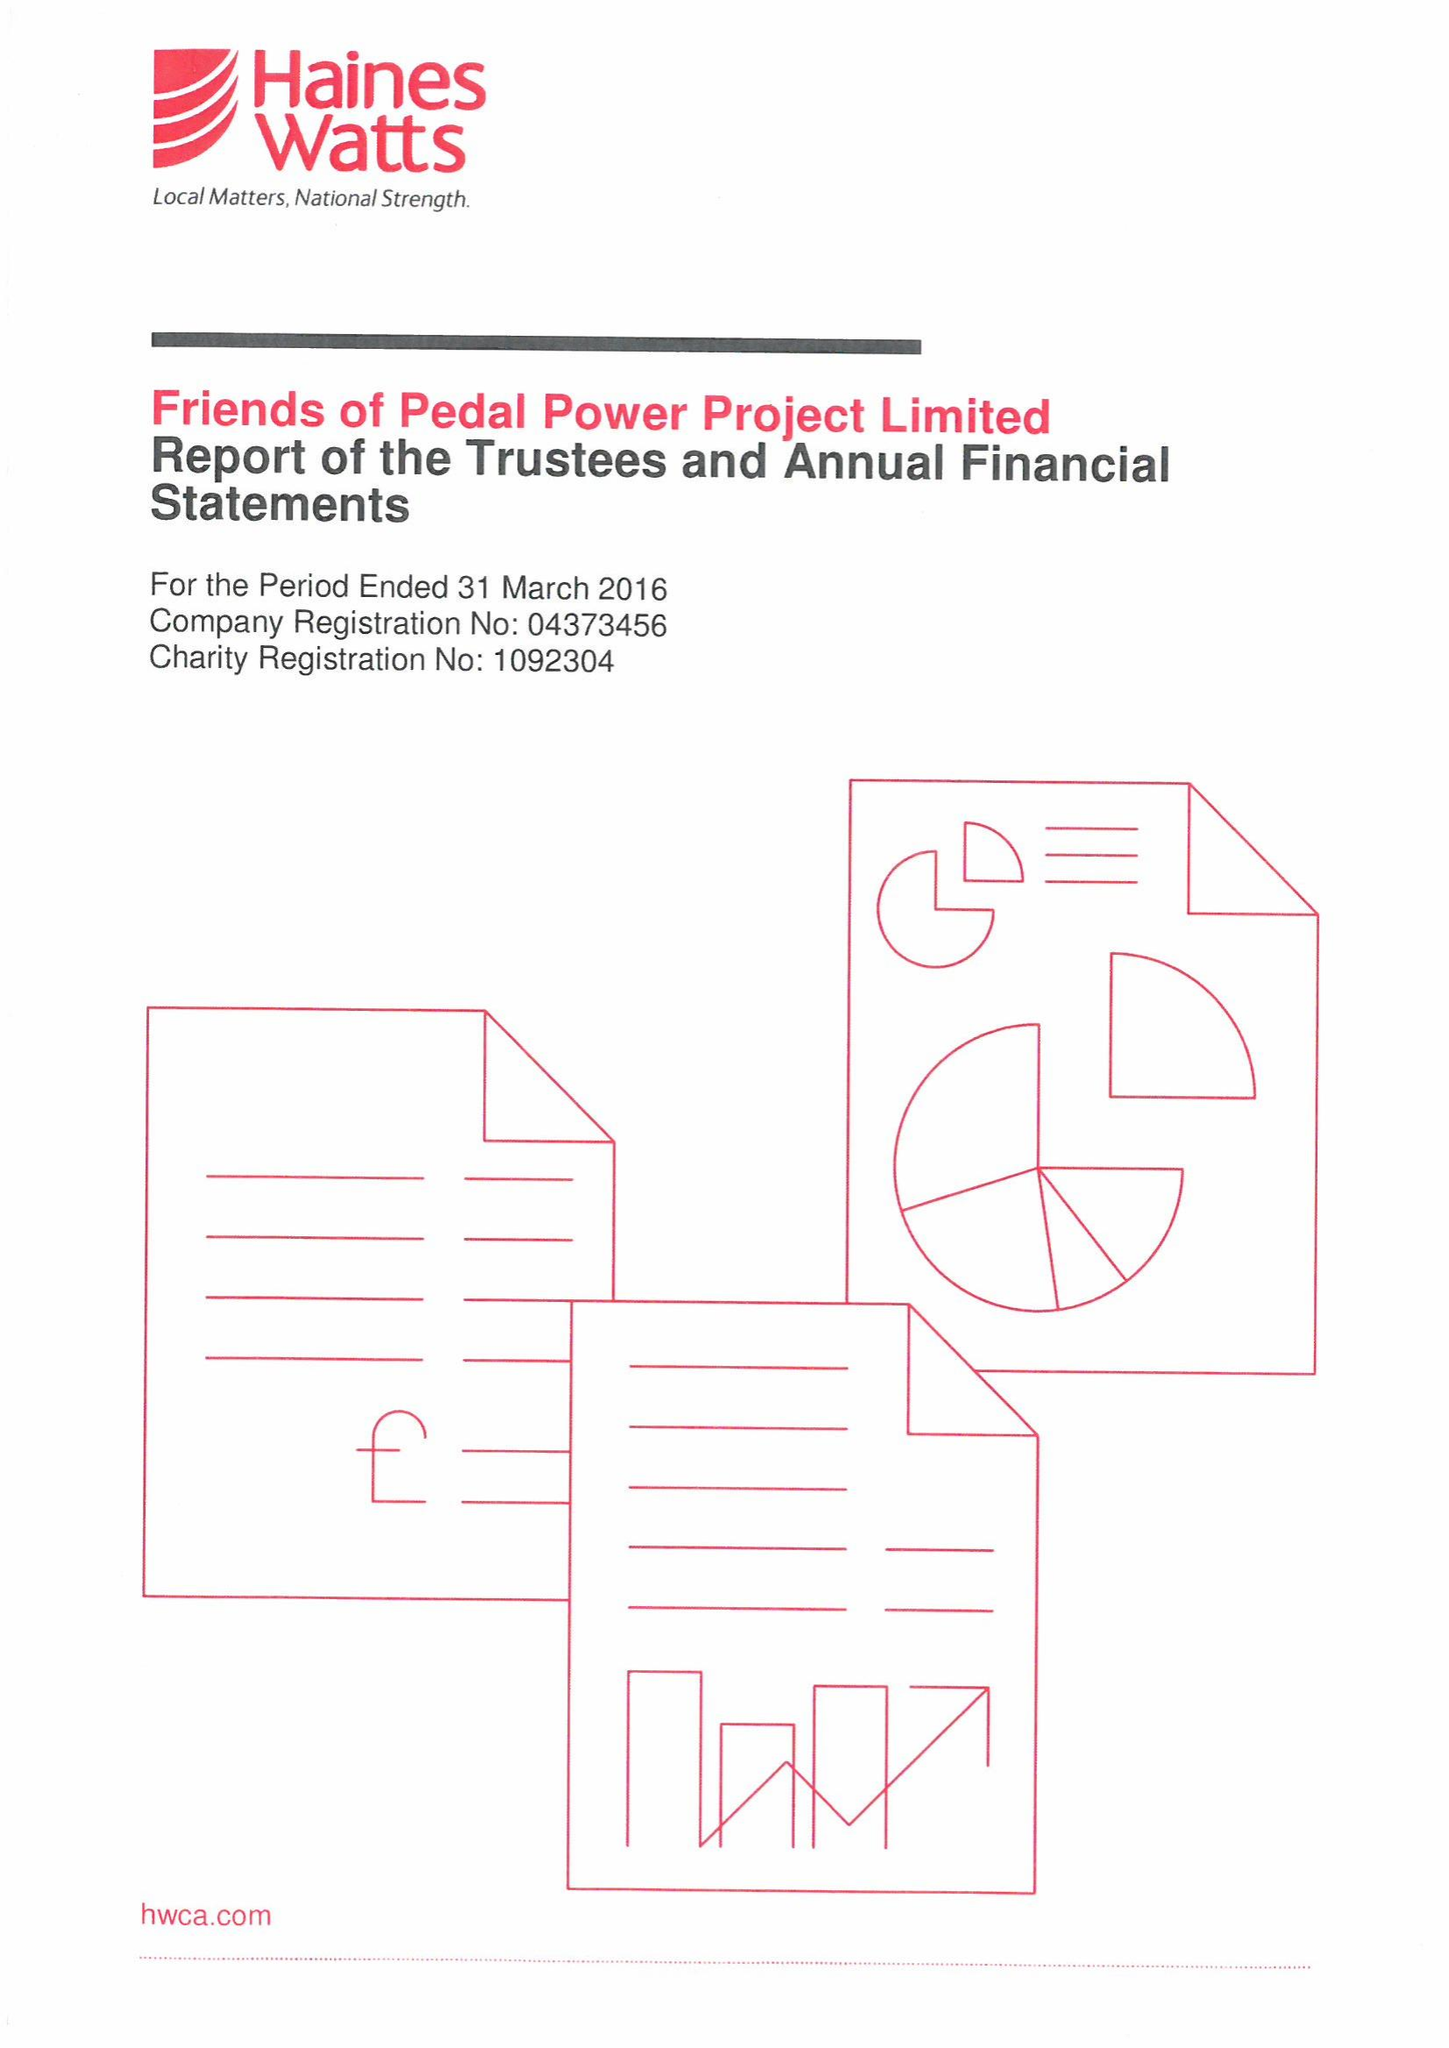What is the value for the address__street_line?
Answer the question using a single word or phrase. OFF DOGO STREET 